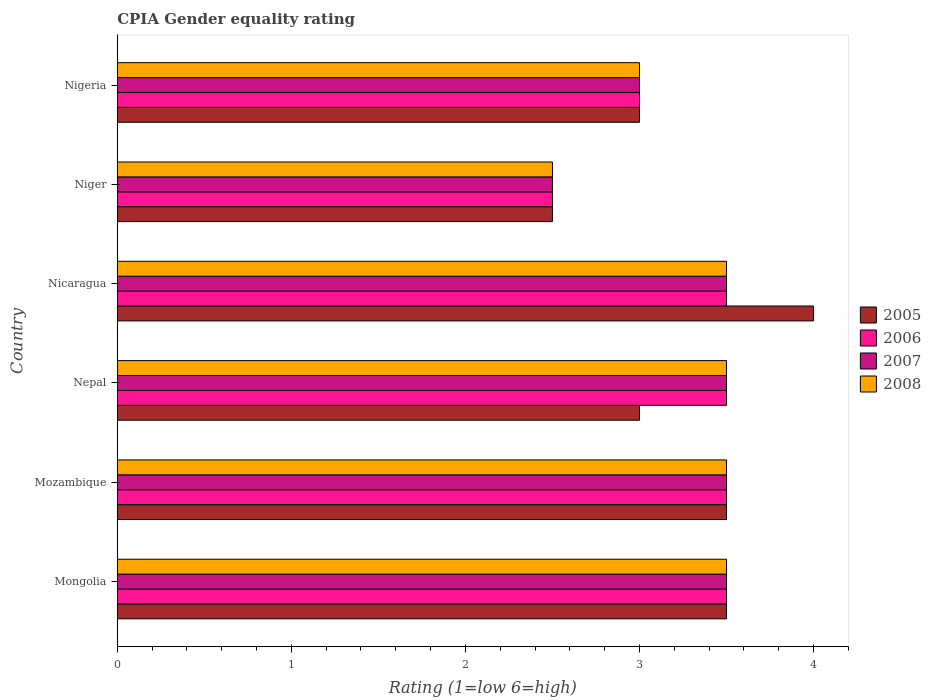How many groups of bars are there?
Provide a succinct answer. 6. Are the number of bars per tick equal to the number of legend labels?
Make the answer very short. Yes. What is the label of the 5th group of bars from the top?
Make the answer very short. Mozambique. What is the CPIA rating in 2005 in Mongolia?
Offer a terse response. 3.5. Across all countries, what is the maximum CPIA rating in 2006?
Make the answer very short. 3.5. Across all countries, what is the minimum CPIA rating in 2005?
Provide a succinct answer. 2.5. In which country was the CPIA rating in 2008 maximum?
Ensure brevity in your answer.  Mongolia. In which country was the CPIA rating in 2007 minimum?
Offer a terse response. Niger. What is the total CPIA rating in 2006 in the graph?
Your answer should be very brief. 19.5. What is the difference between the CPIA rating in 2005 in Nepal and that in Nicaragua?
Offer a terse response. -1. What is the difference between the CPIA rating in 2005 and CPIA rating in 2008 in Nigeria?
Ensure brevity in your answer.  0. Is the CPIA rating in 2005 in Mozambique less than that in Nigeria?
Your answer should be compact. No. Is the difference between the CPIA rating in 2005 in Nicaragua and Niger greater than the difference between the CPIA rating in 2008 in Nicaragua and Niger?
Offer a very short reply. Yes. In how many countries, is the CPIA rating in 2007 greater than the average CPIA rating in 2007 taken over all countries?
Your response must be concise. 4. Is it the case that in every country, the sum of the CPIA rating in 2005 and CPIA rating in 2007 is greater than the sum of CPIA rating in 2006 and CPIA rating in 2008?
Keep it short and to the point. No. What does the 3rd bar from the top in Mongolia represents?
Provide a succinct answer. 2006. What does the 1st bar from the bottom in Mozambique represents?
Your answer should be compact. 2005. Is it the case that in every country, the sum of the CPIA rating in 2008 and CPIA rating in 2007 is greater than the CPIA rating in 2005?
Offer a very short reply. Yes. Are the values on the major ticks of X-axis written in scientific E-notation?
Provide a short and direct response. No. Does the graph contain grids?
Offer a terse response. No. How are the legend labels stacked?
Your answer should be very brief. Vertical. What is the title of the graph?
Keep it short and to the point. CPIA Gender equality rating. Does "1973" appear as one of the legend labels in the graph?
Your answer should be very brief. No. What is the label or title of the X-axis?
Provide a short and direct response. Rating (1=low 6=high). What is the Rating (1=low 6=high) in 2007 in Mongolia?
Make the answer very short. 3.5. What is the Rating (1=low 6=high) in 2005 in Mozambique?
Your answer should be compact. 3.5. What is the Rating (1=low 6=high) of 2006 in Mozambique?
Give a very brief answer. 3.5. What is the Rating (1=low 6=high) of 2007 in Mozambique?
Offer a terse response. 3.5. What is the Rating (1=low 6=high) of 2008 in Mozambique?
Offer a very short reply. 3.5. What is the Rating (1=low 6=high) in 2005 in Nepal?
Give a very brief answer. 3. What is the Rating (1=low 6=high) in 2007 in Nepal?
Make the answer very short. 3.5. What is the Rating (1=low 6=high) of 2006 in Nicaragua?
Your answer should be compact. 3.5. What is the Rating (1=low 6=high) in 2007 in Nicaragua?
Keep it short and to the point. 3.5. What is the Rating (1=low 6=high) in 2008 in Nicaragua?
Your answer should be compact. 3.5. What is the Rating (1=low 6=high) in 2005 in Niger?
Provide a short and direct response. 2.5. What is the Rating (1=low 6=high) of 2006 in Niger?
Offer a very short reply. 2.5. What is the Rating (1=low 6=high) in 2007 in Niger?
Make the answer very short. 2.5. What is the Rating (1=low 6=high) in 2006 in Nigeria?
Your response must be concise. 3. Across all countries, what is the maximum Rating (1=low 6=high) in 2005?
Give a very brief answer. 4. Across all countries, what is the maximum Rating (1=low 6=high) in 2007?
Your answer should be very brief. 3.5. Across all countries, what is the maximum Rating (1=low 6=high) in 2008?
Your answer should be very brief. 3.5. Across all countries, what is the minimum Rating (1=low 6=high) in 2005?
Ensure brevity in your answer.  2.5. Across all countries, what is the minimum Rating (1=low 6=high) in 2008?
Your response must be concise. 2.5. What is the total Rating (1=low 6=high) of 2005 in the graph?
Your response must be concise. 19.5. What is the total Rating (1=low 6=high) in 2006 in the graph?
Ensure brevity in your answer.  19.5. What is the total Rating (1=low 6=high) of 2007 in the graph?
Provide a succinct answer. 19.5. What is the difference between the Rating (1=low 6=high) in 2006 in Mongolia and that in Mozambique?
Provide a succinct answer. 0. What is the difference between the Rating (1=low 6=high) of 2007 in Mongolia and that in Mozambique?
Offer a terse response. 0. What is the difference between the Rating (1=low 6=high) of 2008 in Mongolia and that in Mozambique?
Your answer should be very brief. 0. What is the difference between the Rating (1=low 6=high) in 2005 in Mongolia and that in Nepal?
Make the answer very short. 0.5. What is the difference between the Rating (1=low 6=high) in 2006 in Mongolia and that in Nepal?
Make the answer very short. 0. What is the difference between the Rating (1=low 6=high) of 2007 in Mongolia and that in Nepal?
Your answer should be very brief. 0. What is the difference between the Rating (1=low 6=high) of 2008 in Mongolia and that in Nepal?
Offer a terse response. 0. What is the difference between the Rating (1=low 6=high) in 2006 in Mongolia and that in Nicaragua?
Provide a succinct answer. 0. What is the difference between the Rating (1=low 6=high) of 2005 in Mongolia and that in Niger?
Offer a terse response. 1. What is the difference between the Rating (1=low 6=high) of 2007 in Mongolia and that in Niger?
Your response must be concise. 1. What is the difference between the Rating (1=low 6=high) in 2008 in Mongolia and that in Nigeria?
Provide a succinct answer. 0.5. What is the difference between the Rating (1=low 6=high) of 2005 in Mozambique and that in Nepal?
Provide a succinct answer. 0.5. What is the difference between the Rating (1=low 6=high) in 2006 in Mozambique and that in Nepal?
Offer a terse response. 0. What is the difference between the Rating (1=low 6=high) in 2006 in Mozambique and that in Nicaragua?
Ensure brevity in your answer.  0. What is the difference between the Rating (1=low 6=high) in 2005 in Mozambique and that in Niger?
Ensure brevity in your answer.  1. What is the difference between the Rating (1=low 6=high) in 2007 in Mozambique and that in Niger?
Provide a succinct answer. 1. What is the difference between the Rating (1=low 6=high) in 2007 in Nepal and that in Nicaragua?
Offer a very short reply. 0. What is the difference between the Rating (1=low 6=high) of 2008 in Nepal and that in Nicaragua?
Your response must be concise. 0. What is the difference between the Rating (1=low 6=high) in 2005 in Nepal and that in Niger?
Provide a succinct answer. 0.5. What is the difference between the Rating (1=low 6=high) in 2005 in Nepal and that in Nigeria?
Your response must be concise. 0. What is the difference between the Rating (1=low 6=high) in 2006 in Nepal and that in Nigeria?
Make the answer very short. 0.5. What is the difference between the Rating (1=low 6=high) in 2006 in Nicaragua and that in Niger?
Keep it short and to the point. 1. What is the difference between the Rating (1=low 6=high) of 2007 in Nicaragua and that in Niger?
Offer a very short reply. 1. What is the difference between the Rating (1=low 6=high) in 2008 in Nicaragua and that in Niger?
Provide a succinct answer. 1. What is the difference between the Rating (1=low 6=high) of 2005 in Nicaragua and that in Nigeria?
Ensure brevity in your answer.  1. What is the difference between the Rating (1=low 6=high) of 2007 in Nicaragua and that in Nigeria?
Provide a succinct answer. 0.5. What is the difference between the Rating (1=low 6=high) in 2008 in Nicaragua and that in Nigeria?
Provide a succinct answer. 0.5. What is the difference between the Rating (1=low 6=high) of 2007 in Niger and that in Nigeria?
Give a very brief answer. -0.5. What is the difference between the Rating (1=low 6=high) in 2005 in Mongolia and the Rating (1=low 6=high) in 2007 in Mozambique?
Give a very brief answer. 0. What is the difference between the Rating (1=low 6=high) in 2006 in Mongolia and the Rating (1=low 6=high) in 2008 in Mozambique?
Provide a short and direct response. 0. What is the difference between the Rating (1=low 6=high) of 2005 in Mongolia and the Rating (1=low 6=high) of 2007 in Nepal?
Offer a terse response. 0. What is the difference between the Rating (1=low 6=high) of 2005 in Mongolia and the Rating (1=low 6=high) of 2008 in Nepal?
Make the answer very short. 0. What is the difference between the Rating (1=low 6=high) in 2006 in Mongolia and the Rating (1=low 6=high) in 2007 in Nepal?
Your response must be concise. 0. What is the difference between the Rating (1=low 6=high) of 2006 in Mongolia and the Rating (1=low 6=high) of 2008 in Nepal?
Ensure brevity in your answer.  0. What is the difference between the Rating (1=low 6=high) of 2005 in Mongolia and the Rating (1=low 6=high) of 2006 in Nicaragua?
Offer a very short reply. 0. What is the difference between the Rating (1=low 6=high) in 2005 in Mongolia and the Rating (1=low 6=high) in 2007 in Nicaragua?
Offer a very short reply. 0. What is the difference between the Rating (1=low 6=high) of 2005 in Mongolia and the Rating (1=low 6=high) of 2008 in Nicaragua?
Offer a terse response. 0. What is the difference between the Rating (1=low 6=high) in 2006 in Mongolia and the Rating (1=low 6=high) in 2008 in Nicaragua?
Your answer should be compact. 0. What is the difference between the Rating (1=low 6=high) of 2007 in Mongolia and the Rating (1=low 6=high) of 2008 in Nicaragua?
Your response must be concise. 0. What is the difference between the Rating (1=low 6=high) of 2005 in Mongolia and the Rating (1=low 6=high) of 2006 in Niger?
Your response must be concise. 1. What is the difference between the Rating (1=low 6=high) in 2005 in Mongolia and the Rating (1=low 6=high) in 2007 in Niger?
Your answer should be very brief. 1. What is the difference between the Rating (1=low 6=high) of 2005 in Mongolia and the Rating (1=low 6=high) of 2008 in Niger?
Give a very brief answer. 1. What is the difference between the Rating (1=low 6=high) in 2006 in Mongolia and the Rating (1=low 6=high) in 2007 in Niger?
Make the answer very short. 1. What is the difference between the Rating (1=low 6=high) of 2007 in Mongolia and the Rating (1=low 6=high) of 2008 in Niger?
Your answer should be compact. 1. What is the difference between the Rating (1=low 6=high) of 2005 in Mongolia and the Rating (1=low 6=high) of 2006 in Nigeria?
Offer a terse response. 0.5. What is the difference between the Rating (1=low 6=high) in 2005 in Mongolia and the Rating (1=low 6=high) in 2008 in Nigeria?
Your answer should be compact. 0.5. What is the difference between the Rating (1=low 6=high) in 2006 in Mongolia and the Rating (1=low 6=high) in 2007 in Nigeria?
Offer a terse response. 0.5. What is the difference between the Rating (1=low 6=high) of 2005 in Mozambique and the Rating (1=low 6=high) of 2006 in Nepal?
Provide a short and direct response. 0. What is the difference between the Rating (1=low 6=high) in 2006 in Mozambique and the Rating (1=low 6=high) in 2007 in Nepal?
Keep it short and to the point. 0. What is the difference between the Rating (1=low 6=high) of 2006 in Mozambique and the Rating (1=low 6=high) of 2008 in Nepal?
Your response must be concise. 0. What is the difference between the Rating (1=low 6=high) of 2005 in Mozambique and the Rating (1=low 6=high) of 2006 in Nicaragua?
Your answer should be compact. 0. What is the difference between the Rating (1=low 6=high) in 2005 in Mozambique and the Rating (1=low 6=high) in 2007 in Nicaragua?
Offer a very short reply. 0. What is the difference between the Rating (1=low 6=high) of 2006 in Mozambique and the Rating (1=low 6=high) of 2007 in Nicaragua?
Make the answer very short. 0. What is the difference between the Rating (1=low 6=high) in 2007 in Mozambique and the Rating (1=low 6=high) in 2008 in Nicaragua?
Your answer should be compact. 0. What is the difference between the Rating (1=low 6=high) in 2005 in Mozambique and the Rating (1=low 6=high) in 2008 in Niger?
Your response must be concise. 1. What is the difference between the Rating (1=low 6=high) of 2006 in Mozambique and the Rating (1=low 6=high) of 2007 in Niger?
Give a very brief answer. 1. What is the difference between the Rating (1=low 6=high) in 2006 in Mozambique and the Rating (1=low 6=high) in 2008 in Niger?
Keep it short and to the point. 1. What is the difference between the Rating (1=low 6=high) of 2005 in Mozambique and the Rating (1=low 6=high) of 2007 in Nigeria?
Provide a short and direct response. 0.5. What is the difference between the Rating (1=low 6=high) in 2006 in Mozambique and the Rating (1=low 6=high) in 2007 in Nigeria?
Keep it short and to the point. 0.5. What is the difference between the Rating (1=low 6=high) of 2006 in Mozambique and the Rating (1=low 6=high) of 2008 in Nigeria?
Keep it short and to the point. 0.5. What is the difference between the Rating (1=low 6=high) of 2007 in Mozambique and the Rating (1=low 6=high) of 2008 in Nigeria?
Your answer should be compact. 0.5. What is the difference between the Rating (1=low 6=high) of 2005 in Nepal and the Rating (1=low 6=high) of 2006 in Nicaragua?
Provide a short and direct response. -0.5. What is the difference between the Rating (1=low 6=high) in 2005 in Nepal and the Rating (1=low 6=high) in 2007 in Nicaragua?
Give a very brief answer. -0.5. What is the difference between the Rating (1=low 6=high) in 2006 in Nepal and the Rating (1=low 6=high) in 2007 in Nicaragua?
Offer a terse response. 0. What is the difference between the Rating (1=low 6=high) in 2006 in Nepal and the Rating (1=low 6=high) in 2008 in Nicaragua?
Your answer should be very brief. 0. What is the difference between the Rating (1=low 6=high) of 2007 in Nepal and the Rating (1=low 6=high) of 2008 in Nicaragua?
Your answer should be compact. 0. What is the difference between the Rating (1=low 6=high) of 2005 in Nepal and the Rating (1=low 6=high) of 2006 in Niger?
Offer a terse response. 0.5. What is the difference between the Rating (1=low 6=high) of 2006 in Nepal and the Rating (1=low 6=high) of 2007 in Niger?
Offer a very short reply. 1. What is the difference between the Rating (1=low 6=high) in 2006 in Nepal and the Rating (1=low 6=high) in 2008 in Niger?
Keep it short and to the point. 1. What is the difference between the Rating (1=low 6=high) in 2005 in Nepal and the Rating (1=low 6=high) in 2006 in Nigeria?
Your response must be concise. 0. What is the difference between the Rating (1=low 6=high) of 2005 in Nepal and the Rating (1=low 6=high) of 2007 in Nigeria?
Your response must be concise. 0. What is the difference between the Rating (1=low 6=high) of 2005 in Nepal and the Rating (1=low 6=high) of 2008 in Nigeria?
Keep it short and to the point. 0. What is the difference between the Rating (1=low 6=high) of 2006 in Nepal and the Rating (1=low 6=high) of 2007 in Nigeria?
Provide a succinct answer. 0.5. What is the difference between the Rating (1=low 6=high) of 2007 in Nepal and the Rating (1=low 6=high) of 2008 in Nigeria?
Offer a very short reply. 0.5. What is the difference between the Rating (1=low 6=high) of 2005 in Nicaragua and the Rating (1=low 6=high) of 2006 in Niger?
Give a very brief answer. 1.5. What is the difference between the Rating (1=low 6=high) of 2006 in Nicaragua and the Rating (1=low 6=high) of 2008 in Niger?
Provide a short and direct response. 1. What is the difference between the Rating (1=low 6=high) in 2005 in Nicaragua and the Rating (1=low 6=high) in 2006 in Nigeria?
Ensure brevity in your answer.  1. What is the difference between the Rating (1=low 6=high) of 2006 in Nicaragua and the Rating (1=low 6=high) of 2008 in Nigeria?
Your response must be concise. 0.5. What is the difference between the Rating (1=low 6=high) in 2005 in Niger and the Rating (1=low 6=high) in 2007 in Nigeria?
Provide a succinct answer. -0.5. What is the difference between the Rating (1=low 6=high) in 2005 in Niger and the Rating (1=low 6=high) in 2008 in Nigeria?
Keep it short and to the point. -0.5. What is the difference between the Rating (1=low 6=high) in 2006 in Niger and the Rating (1=low 6=high) in 2007 in Nigeria?
Keep it short and to the point. -0.5. What is the difference between the Rating (1=low 6=high) in 2006 in Niger and the Rating (1=low 6=high) in 2008 in Nigeria?
Keep it short and to the point. -0.5. What is the average Rating (1=low 6=high) of 2006 per country?
Provide a succinct answer. 3.25. What is the average Rating (1=low 6=high) in 2007 per country?
Offer a very short reply. 3.25. What is the average Rating (1=low 6=high) in 2008 per country?
Keep it short and to the point. 3.25. What is the difference between the Rating (1=low 6=high) of 2005 and Rating (1=low 6=high) of 2006 in Mongolia?
Give a very brief answer. 0. What is the difference between the Rating (1=low 6=high) of 2005 and Rating (1=low 6=high) of 2007 in Mongolia?
Provide a succinct answer. 0. What is the difference between the Rating (1=low 6=high) of 2005 and Rating (1=low 6=high) of 2008 in Mongolia?
Offer a very short reply. 0. What is the difference between the Rating (1=low 6=high) in 2006 and Rating (1=low 6=high) in 2007 in Mongolia?
Keep it short and to the point. 0. What is the difference between the Rating (1=low 6=high) of 2007 and Rating (1=low 6=high) of 2008 in Mongolia?
Offer a very short reply. 0. What is the difference between the Rating (1=low 6=high) of 2005 and Rating (1=low 6=high) of 2006 in Mozambique?
Provide a succinct answer. 0. What is the difference between the Rating (1=low 6=high) of 2005 and Rating (1=low 6=high) of 2008 in Mozambique?
Offer a terse response. 0. What is the difference between the Rating (1=low 6=high) of 2006 and Rating (1=low 6=high) of 2007 in Mozambique?
Offer a very short reply. 0. What is the difference between the Rating (1=low 6=high) of 2005 and Rating (1=low 6=high) of 2006 in Nepal?
Your answer should be very brief. -0.5. What is the difference between the Rating (1=low 6=high) in 2005 and Rating (1=low 6=high) in 2006 in Nicaragua?
Your answer should be very brief. 0.5. What is the difference between the Rating (1=low 6=high) of 2006 and Rating (1=low 6=high) of 2008 in Nicaragua?
Your response must be concise. 0. What is the difference between the Rating (1=low 6=high) of 2007 and Rating (1=low 6=high) of 2008 in Nicaragua?
Provide a short and direct response. 0. What is the difference between the Rating (1=low 6=high) of 2005 and Rating (1=low 6=high) of 2007 in Niger?
Offer a very short reply. 0. What is the difference between the Rating (1=low 6=high) of 2006 and Rating (1=low 6=high) of 2007 in Niger?
Provide a short and direct response. 0. What is the difference between the Rating (1=low 6=high) in 2007 and Rating (1=low 6=high) in 2008 in Niger?
Your answer should be compact. 0. What is the difference between the Rating (1=low 6=high) of 2005 and Rating (1=low 6=high) of 2006 in Nigeria?
Your response must be concise. 0. What is the difference between the Rating (1=low 6=high) of 2005 and Rating (1=low 6=high) of 2008 in Nigeria?
Provide a succinct answer. 0. What is the difference between the Rating (1=low 6=high) in 2006 and Rating (1=low 6=high) in 2007 in Nigeria?
Provide a short and direct response. 0. What is the ratio of the Rating (1=low 6=high) of 2008 in Mongolia to that in Mozambique?
Keep it short and to the point. 1. What is the ratio of the Rating (1=low 6=high) of 2007 in Mongolia to that in Nepal?
Your response must be concise. 1. What is the ratio of the Rating (1=low 6=high) of 2005 in Mongolia to that in Nicaragua?
Keep it short and to the point. 0.88. What is the ratio of the Rating (1=low 6=high) in 2006 in Mongolia to that in Nicaragua?
Provide a succinct answer. 1. What is the ratio of the Rating (1=low 6=high) in 2007 in Mongolia to that in Nicaragua?
Your answer should be very brief. 1. What is the ratio of the Rating (1=low 6=high) of 2005 in Mongolia to that in Niger?
Offer a terse response. 1.4. What is the ratio of the Rating (1=low 6=high) in 2006 in Mongolia to that in Niger?
Provide a short and direct response. 1.4. What is the ratio of the Rating (1=low 6=high) of 2008 in Mongolia to that in Niger?
Keep it short and to the point. 1.4. What is the ratio of the Rating (1=low 6=high) in 2005 in Mongolia to that in Nigeria?
Provide a succinct answer. 1.17. What is the ratio of the Rating (1=low 6=high) in 2008 in Mongolia to that in Nigeria?
Ensure brevity in your answer.  1.17. What is the ratio of the Rating (1=low 6=high) of 2005 in Mozambique to that in Nepal?
Make the answer very short. 1.17. What is the ratio of the Rating (1=low 6=high) of 2006 in Mozambique to that in Nepal?
Your answer should be compact. 1. What is the ratio of the Rating (1=low 6=high) of 2007 in Mozambique to that in Nepal?
Provide a short and direct response. 1. What is the ratio of the Rating (1=low 6=high) in 2006 in Mozambique to that in Niger?
Your answer should be very brief. 1.4. What is the ratio of the Rating (1=low 6=high) in 2007 in Mozambique to that in Niger?
Ensure brevity in your answer.  1.4. What is the ratio of the Rating (1=low 6=high) in 2008 in Mozambique to that in Niger?
Offer a very short reply. 1.4. What is the ratio of the Rating (1=low 6=high) of 2005 in Mozambique to that in Nigeria?
Provide a short and direct response. 1.17. What is the ratio of the Rating (1=low 6=high) of 2005 in Nepal to that in Niger?
Make the answer very short. 1.2. What is the ratio of the Rating (1=low 6=high) in 2005 in Nicaragua to that in Niger?
Offer a terse response. 1.6. What is the ratio of the Rating (1=low 6=high) of 2005 in Nicaragua to that in Nigeria?
Offer a terse response. 1.33. What is the ratio of the Rating (1=low 6=high) of 2006 in Niger to that in Nigeria?
Make the answer very short. 0.83. What is the difference between the highest and the second highest Rating (1=low 6=high) of 2005?
Provide a short and direct response. 0.5. What is the difference between the highest and the second highest Rating (1=low 6=high) in 2007?
Your answer should be very brief. 0. What is the difference between the highest and the lowest Rating (1=low 6=high) of 2006?
Give a very brief answer. 1. What is the difference between the highest and the lowest Rating (1=low 6=high) of 2007?
Provide a succinct answer. 1. What is the difference between the highest and the lowest Rating (1=low 6=high) of 2008?
Your answer should be very brief. 1. 